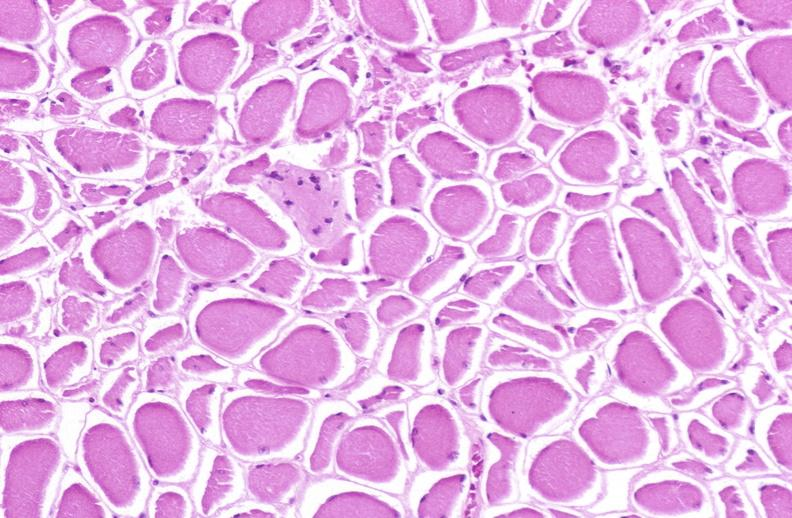s soft tissue present?
Answer the question using a single word or phrase. Yes 